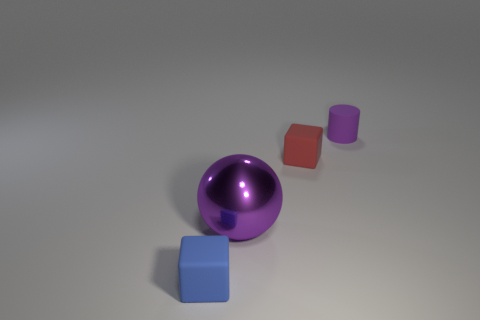What number of other objects are there of the same material as the sphere?
Your answer should be compact. 0. Is there any other thing that has the same size as the purple sphere?
Make the answer very short. No. Are there any matte cylinders that have the same color as the large metallic thing?
Your response must be concise. Yes. Do the thing behind the red matte object and the large metal object have the same color?
Provide a succinct answer. Yes. How many objects are tiny things on the left side of the purple matte cylinder or metallic balls?
Give a very brief answer. 3. There is a red rubber thing; are there any small red objects in front of it?
Keep it short and to the point. No. There is a thing that is the same color as the shiny sphere; what is it made of?
Provide a succinct answer. Rubber. Does the small object that is in front of the purple metallic ball have the same material as the purple cylinder?
Provide a short and direct response. Yes. Is there a large purple metallic ball left of the small rubber block that is to the right of the small object left of the purple sphere?
Ensure brevity in your answer.  Yes. What number of spheres are tiny purple matte objects or small blue rubber things?
Your answer should be very brief. 0. 